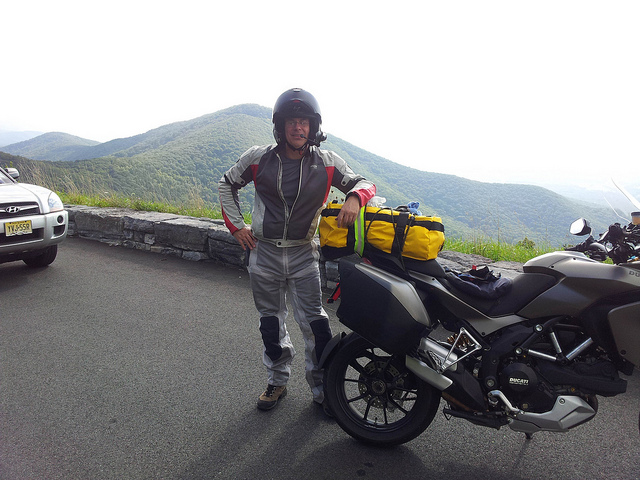Extract all visible text content from this image. TESCO 